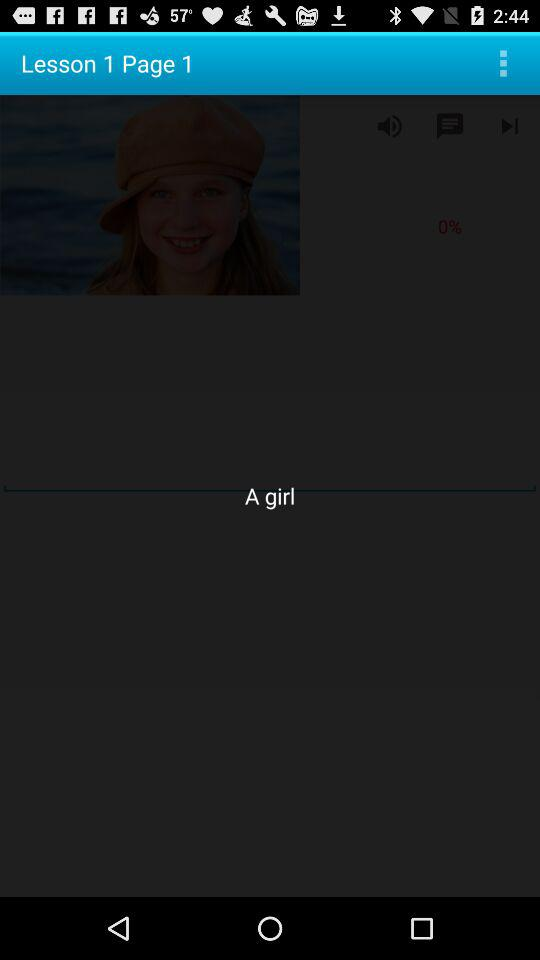Which lesson is displayed? The displayed lesson is 1. 